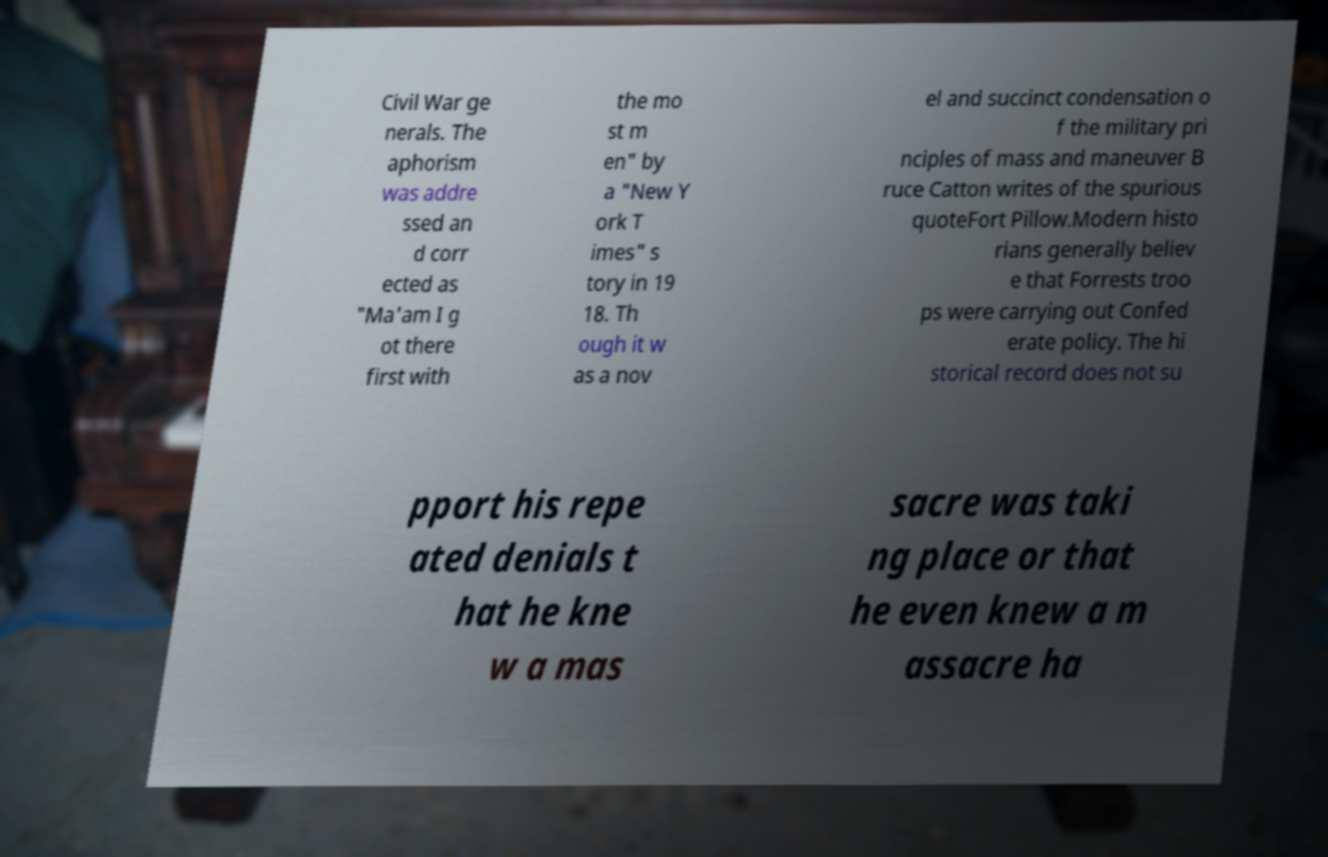Could you assist in decoding the text presented in this image and type it out clearly? Certainly! The text in the image discusses a Civil War anecdote and reads: 'Civil War generals. The aphorism was addressed and corrected as "Ma'am I got there first with the most men" by a "New York Times" story in 1918. Though it was a novel and succinct condensation of the military principles of mass and maneuver, Bruce Catton writes of the spurious quote Fort Pillow. Modern historians generally believe that Forrest's troops were carrying out Confederate policy. The historical record does not support his repeated denials that he knew a massacre was taking place or that he even knew a massacre ha[cut off]'. 